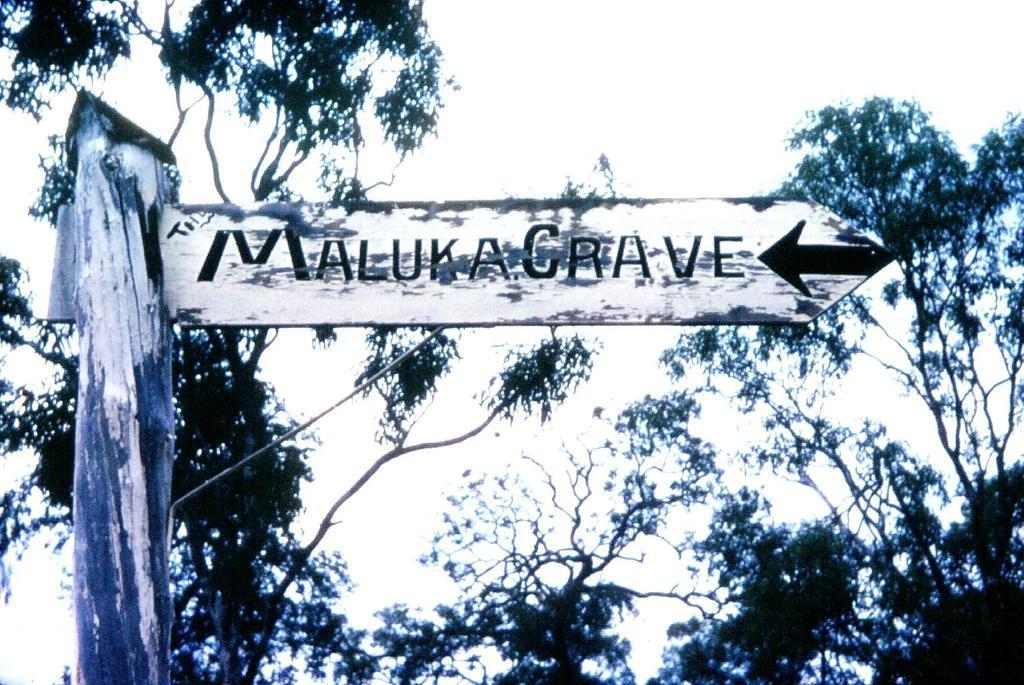Please provide a concise description of this image. In the image in the center we can see one pole and one sign board. In the background we can see the sky,clouds and trees. 